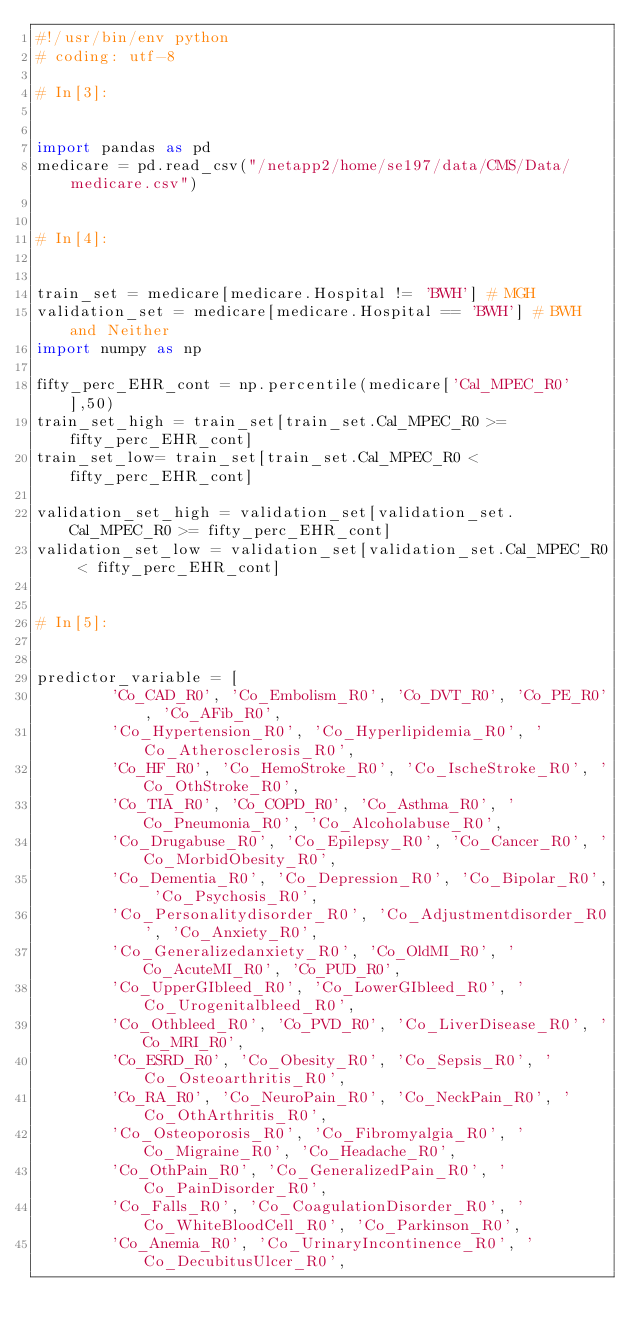<code> <loc_0><loc_0><loc_500><loc_500><_Python_>#!/usr/bin/env python
# coding: utf-8

# In[3]:


import pandas as pd
medicare = pd.read_csv("/netapp2/home/se197/data/CMS/Data/medicare.csv")


# In[4]:


train_set = medicare[medicare.Hospital != 'BWH'] # MGH
validation_set = medicare[medicare.Hospital == 'BWH'] # BWH and Neither 
import numpy as np

fifty_perc_EHR_cont = np.percentile(medicare['Cal_MPEC_R0'],50)
train_set_high = train_set[train_set.Cal_MPEC_R0 >= fifty_perc_EHR_cont]
train_set_low= train_set[train_set.Cal_MPEC_R0 < fifty_perc_EHR_cont]

validation_set_high = validation_set[validation_set.Cal_MPEC_R0 >= fifty_perc_EHR_cont]
validation_set_low = validation_set[validation_set.Cal_MPEC_R0 < fifty_perc_EHR_cont]


# In[5]:


predictor_variable = [
        'Co_CAD_R0', 'Co_Embolism_R0', 'Co_DVT_R0', 'Co_PE_R0', 'Co_AFib_R0',
        'Co_Hypertension_R0', 'Co_Hyperlipidemia_R0', 'Co_Atherosclerosis_R0',
        'Co_HF_R0', 'Co_HemoStroke_R0', 'Co_IscheStroke_R0', 'Co_OthStroke_R0',
        'Co_TIA_R0', 'Co_COPD_R0', 'Co_Asthma_R0', 'Co_Pneumonia_R0', 'Co_Alcoholabuse_R0',
        'Co_Drugabuse_R0', 'Co_Epilepsy_R0', 'Co_Cancer_R0', 'Co_MorbidObesity_R0',
        'Co_Dementia_R0', 'Co_Depression_R0', 'Co_Bipolar_R0', 'Co_Psychosis_R0',
        'Co_Personalitydisorder_R0', 'Co_Adjustmentdisorder_R0', 'Co_Anxiety_R0',
        'Co_Generalizedanxiety_R0', 'Co_OldMI_R0', 'Co_AcuteMI_R0', 'Co_PUD_R0',
        'Co_UpperGIbleed_R0', 'Co_LowerGIbleed_R0', 'Co_Urogenitalbleed_R0',
        'Co_Othbleed_R0', 'Co_PVD_R0', 'Co_LiverDisease_R0', 'Co_MRI_R0',
        'Co_ESRD_R0', 'Co_Obesity_R0', 'Co_Sepsis_R0', 'Co_Osteoarthritis_R0',
        'Co_RA_R0', 'Co_NeuroPain_R0', 'Co_NeckPain_R0', 'Co_OthArthritis_R0',
        'Co_Osteoporosis_R0', 'Co_Fibromyalgia_R0', 'Co_Migraine_R0', 'Co_Headache_R0',
        'Co_OthPain_R0', 'Co_GeneralizedPain_R0', 'Co_PainDisorder_R0',
        'Co_Falls_R0', 'Co_CoagulationDisorder_R0', 'Co_WhiteBloodCell_R0', 'Co_Parkinson_R0',
        'Co_Anemia_R0', 'Co_UrinaryIncontinence_R0', 'Co_DecubitusUlcer_R0',</code> 